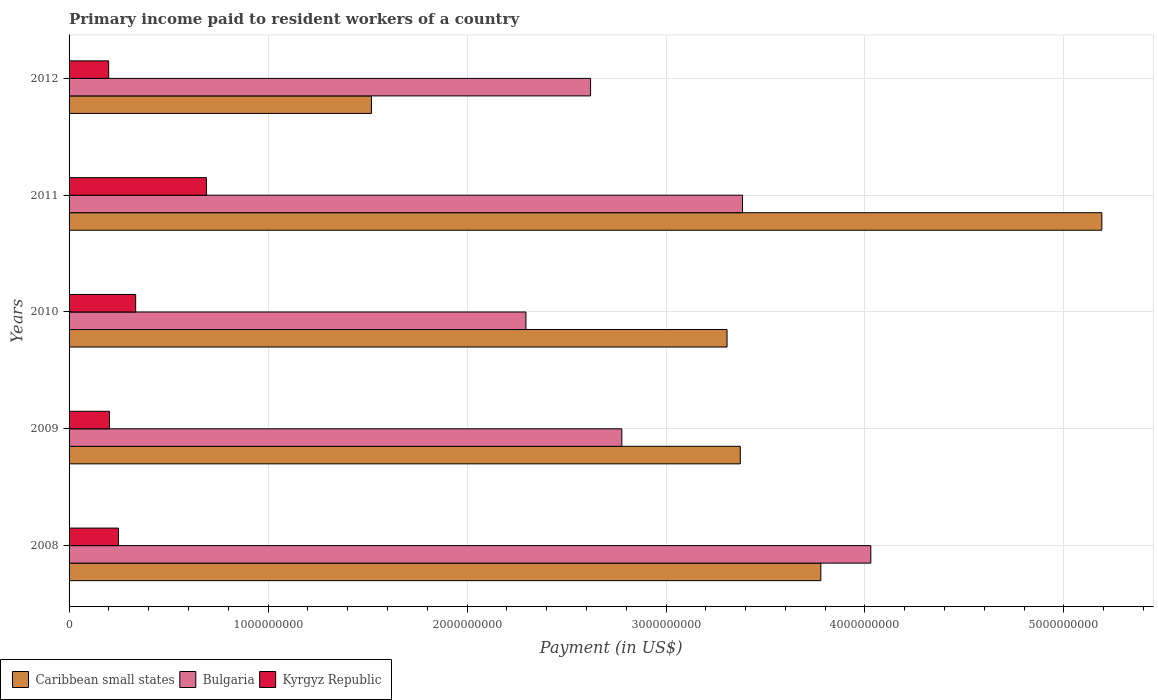How many different coloured bars are there?
Provide a succinct answer. 3. How many groups of bars are there?
Offer a very short reply. 5. Are the number of bars per tick equal to the number of legend labels?
Your answer should be very brief. Yes. Are the number of bars on each tick of the Y-axis equal?
Your response must be concise. Yes. What is the amount paid to workers in Kyrgyz Republic in 2008?
Provide a succinct answer. 2.48e+08. Across all years, what is the maximum amount paid to workers in Kyrgyz Republic?
Give a very brief answer. 6.91e+08. Across all years, what is the minimum amount paid to workers in Bulgaria?
Provide a short and direct response. 2.30e+09. In which year was the amount paid to workers in Bulgaria maximum?
Your response must be concise. 2008. In which year was the amount paid to workers in Caribbean small states minimum?
Offer a very short reply. 2012. What is the total amount paid to workers in Kyrgyz Republic in the graph?
Ensure brevity in your answer.  1.68e+09. What is the difference between the amount paid to workers in Kyrgyz Republic in 2010 and that in 2012?
Ensure brevity in your answer.  1.36e+08. What is the difference between the amount paid to workers in Caribbean small states in 2010 and the amount paid to workers in Bulgaria in 2012?
Offer a very short reply. 6.86e+08. What is the average amount paid to workers in Caribbean small states per year?
Offer a very short reply. 3.43e+09. In the year 2010, what is the difference between the amount paid to workers in Bulgaria and amount paid to workers in Kyrgyz Republic?
Give a very brief answer. 1.96e+09. In how many years, is the amount paid to workers in Kyrgyz Republic greater than 3000000000 US$?
Make the answer very short. 0. What is the ratio of the amount paid to workers in Bulgaria in 2010 to that in 2011?
Provide a succinct answer. 0.68. Is the amount paid to workers in Kyrgyz Republic in 2008 less than that in 2009?
Give a very brief answer. No. Is the difference between the amount paid to workers in Bulgaria in 2010 and 2011 greater than the difference between the amount paid to workers in Kyrgyz Republic in 2010 and 2011?
Provide a short and direct response. No. What is the difference between the highest and the second highest amount paid to workers in Bulgaria?
Provide a succinct answer. 6.45e+08. What is the difference between the highest and the lowest amount paid to workers in Kyrgyz Republic?
Your response must be concise. 4.92e+08. Is the sum of the amount paid to workers in Caribbean small states in 2008 and 2010 greater than the maximum amount paid to workers in Bulgaria across all years?
Make the answer very short. Yes. What does the 2nd bar from the top in 2008 represents?
Provide a succinct answer. Bulgaria. What does the 1st bar from the bottom in 2011 represents?
Your answer should be compact. Caribbean small states. How many bars are there?
Provide a succinct answer. 15. Are all the bars in the graph horizontal?
Your answer should be compact. Yes. Are the values on the major ticks of X-axis written in scientific E-notation?
Your answer should be compact. No. Does the graph contain grids?
Offer a terse response. Yes. How are the legend labels stacked?
Provide a short and direct response. Horizontal. What is the title of the graph?
Give a very brief answer. Primary income paid to resident workers of a country. Does "Ethiopia" appear as one of the legend labels in the graph?
Offer a very short reply. No. What is the label or title of the X-axis?
Ensure brevity in your answer.  Payment (in US$). What is the Payment (in US$) in Caribbean small states in 2008?
Give a very brief answer. 3.78e+09. What is the Payment (in US$) in Bulgaria in 2008?
Make the answer very short. 4.03e+09. What is the Payment (in US$) in Kyrgyz Republic in 2008?
Keep it short and to the point. 2.48e+08. What is the Payment (in US$) in Caribbean small states in 2009?
Ensure brevity in your answer.  3.37e+09. What is the Payment (in US$) in Bulgaria in 2009?
Your answer should be very brief. 2.78e+09. What is the Payment (in US$) of Kyrgyz Republic in 2009?
Keep it short and to the point. 2.03e+08. What is the Payment (in US$) of Caribbean small states in 2010?
Ensure brevity in your answer.  3.31e+09. What is the Payment (in US$) of Bulgaria in 2010?
Your answer should be compact. 2.30e+09. What is the Payment (in US$) of Kyrgyz Republic in 2010?
Your answer should be compact. 3.35e+08. What is the Payment (in US$) in Caribbean small states in 2011?
Your answer should be compact. 5.19e+09. What is the Payment (in US$) of Bulgaria in 2011?
Your response must be concise. 3.38e+09. What is the Payment (in US$) of Kyrgyz Republic in 2011?
Your response must be concise. 6.91e+08. What is the Payment (in US$) of Caribbean small states in 2012?
Give a very brief answer. 1.52e+09. What is the Payment (in US$) of Bulgaria in 2012?
Give a very brief answer. 2.62e+09. What is the Payment (in US$) of Kyrgyz Republic in 2012?
Offer a very short reply. 1.99e+08. Across all years, what is the maximum Payment (in US$) in Caribbean small states?
Your response must be concise. 5.19e+09. Across all years, what is the maximum Payment (in US$) of Bulgaria?
Give a very brief answer. 4.03e+09. Across all years, what is the maximum Payment (in US$) of Kyrgyz Republic?
Your answer should be compact. 6.91e+08. Across all years, what is the minimum Payment (in US$) of Caribbean small states?
Your response must be concise. 1.52e+09. Across all years, what is the minimum Payment (in US$) of Bulgaria?
Keep it short and to the point. 2.30e+09. Across all years, what is the minimum Payment (in US$) in Kyrgyz Republic?
Keep it short and to the point. 1.99e+08. What is the total Payment (in US$) in Caribbean small states in the graph?
Provide a succinct answer. 1.72e+1. What is the total Payment (in US$) of Bulgaria in the graph?
Make the answer very short. 1.51e+1. What is the total Payment (in US$) of Kyrgyz Republic in the graph?
Offer a very short reply. 1.68e+09. What is the difference between the Payment (in US$) of Caribbean small states in 2008 and that in 2009?
Your response must be concise. 4.05e+08. What is the difference between the Payment (in US$) in Bulgaria in 2008 and that in 2009?
Provide a succinct answer. 1.25e+09. What is the difference between the Payment (in US$) in Kyrgyz Republic in 2008 and that in 2009?
Provide a succinct answer. 4.53e+07. What is the difference between the Payment (in US$) in Caribbean small states in 2008 and that in 2010?
Your answer should be compact. 4.71e+08. What is the difference between the Payment (in US$) of Bulgaria in 2008 and that in 2010?
Provide a short and direct response. 1.73e+09. What is the difference between the Payment (in US$) in Kyrgyz Republic in 2008 and that in 2010?
Keep it short and to the point. -8.63e+07. What is the difference between the Payment (in US$) of Caribbean small states in 2008 and that in 2011?
Ensure brevity in your answer.  -1.41e+09. What is the difference between the Payment (in US$) of Bulgaria in 2008 and that in 2011?
Keep it short and to the point. 6.45e+08. What is the difference between the Payment (in US$) in Kyrgyz Republic in 2008 and that in 2011?
Provide a short and direct response. -4.42e+08. What is the difference between the Payment (in US$) in Caribbean small states in 2008 and that in 2012?
Offer a very short reply. 2.26e+09. What is the difference between the Payment (in US$) of Bulgaria in 2008 and that in 2012?
Offer a terse response. 1.41e+09. What is the difference between the Payment (in US$) in Kyrgyz Republic in 2008 and that in 2012?
Ensure brevity in your answer.  4.94e+07. What is the difference between the Payment (in US$) of Caribbean small states in 2009 and that in 2010?
Offer a terse response. 6.67e+07. What is the difference between the Payment (in US$) in Bulgaria in 2009 and that in 2010?
Keep it short and to the point. 4.82e+08. What is the difference between the Payment (in US$) of Kyrgyz Republic in 2009 and that in 2010?
Keep it short and to the point. -1.32e+08. What is the difference between the Payment (in US$) in Caribbean small states in 2009 and that in 2011?
Offer a terse response. -1.82e+09. What is the difference between the Payment (in US$) in Bulgaria in 2009 and that in 2011?
Offer a terse response. -6.07e+08. What is the difference between the Payment (in US$) of Kyrgyz Republic in 2009 and that in 2011?
Your answer should be very brief. -4.88e+08. What is the difference between the Payment (in US$) in Caribbean small states in 2009 and that in 2012?
Ensure brevity in your answer.  1.85e+09. What is the difference between the Payment (in US$) in Bulgaria in 2009 and that in 2012?
Your response must be concise. 1.57e+08. What is the difference between the Payment (in US$) of Kyrgyz Republic in 2009 and that in 2012?
Your answer should be very brief. 4.12e+06. What is the difference between the Payment (in US$) in Caribbean small states in 2010 and that in 2011?
Offer a very short reply. -1.88e+09. What is the difference between the Payment (in US$) in Bulgaria in 2010 and that in 2011?
Give a very brief answer. -1.09e+09. What is the difference between the Payment (in US$) in Kyrgyz Republic in 2010 and that in 2011?
Offer a very short reply. -3.56e+08. What is the difference between the Payment (in US$) of Caribbean small states in 2010 and that in 2012?
Provide a short and direct response. 1.79e+09. What is the difference between the Payment (in US$) in Bulgaria in 2010 and that in 2012?
Provide a succinct answer. -3.25e+08. What is the difference between the Payment (in US$) of Kyrgyz Republic in 2010 and that in 2012?
Your response must be concise. 1.36e+08. What is the difference between the Payment (in US$) of Caribbean small states in 2011 and that in 2012?
Provide a succinct answer. 3.67e+09. What is the difference between the Payment (in US$) of Bulgaria in 2011 and that in 2012?
Give a very brief answer. 7.64e+08. What is the difference between the Payment (in US$) of Kyrgyz Republic in 2011 and that in 2012?
Ensure brevity in your answer.  4.92e+08. What is the difference between the Payment (in US$) in Caribbean small states in 2008 and the Payment (in US$) in Bulgaria in 2009?
Your response must be concise. 1.00e+09. What is the difference between the Payment (in US$) of Caribbean small states in 2008 and the Payment (in US$) of Kyrgyz Republic in 2009?
Offer a very short reply. 3.58e+09. What is the difference between the Payment (in US$) of Bulgaria in 2008 and the Payment (in US$) of Kyrgyz Republic in 2009?
Keep it short and to the point. 3.83e+09. What is the difference between the Payment (in US$) of Caribbean small states in 2008 and the Payment (in US$) of Bulgaria in 2010?
Ensure brevity in your answer.  1.48e+09. What is the difference between the Payment (in US$) of Caribbean small states in 2008 and the Payment (in US$) of Kyrgyz Republic in 2010?
Your answer should be very brief. 3.44e+09. What is the difference between the Payment (in US$) of Bulgaria in 2008 and the Payment (in US$) of Kyrgyz Republic in 2010?
Make the answer very short. 3.69e+09. What is the difference between the Payment (in US$) of Caribbean small states in 2008 and the Payment (in US$) of Bulgaria in 2011?
Give a very brief answer. 3.94e+08. What is the difference between the Payment (in US$) of Caribbean small states in 2008 and the Payment (in US$) of Kyrgyz Republic in 2011?
Ensure brevity in your answer.  3.09e+09. What is the difference between the Payment (in US$) of Bulgaria in 2008 and the Payment (in US$) of Kyrgyz Republic in 2011?
Offer a terse response. 3.34e+09. What is the difference between the Payment (in US$) of Caribbean small states in 2008 and the Payment (in US$) of Bulgaria in 2012?
Provide a short and direct response. 1.16e+09. What is the difference between the Payment (in US$) in Caribbean small states in 2008 and the Payment (in US$) in Kyrgyz Republic in 2012?
Give a very brief answer. 3.58e+09. What is the difference between the Payment (in US$) of Bulgaria in 2008 and the Payment (in US$) of Kyrgyz Republic in 2012?
Make the answer very short. 3.83e+09. What is the difference between the Payment (in US$) in Caribbean small states in 2009 and the Payment (in US$) in Bulgaria in 2010?
Your response must be concise. 1.08e+09. What is the difference between the Payment (in US$) of Caribbean small states in 2009 and the Payment (in US$) of Kyrgyz Republic in 2010?
Your answer should be compact. 3.04e+09. What is the difference between the Payment (in US$) in Bulgaria in 2009 and the Payment (in US$) in Kyrgyz Republic in 2010?
Your answer should be very brief. 2.44e+09. What is the difference between the Payment (in US$) of Caribbean small states in 2009 and the Payment (in US$) of Bulgaria in 2011?
Ensure brevity in your answer.  -1.11e+07. What is the difference between the Payment (in US$) of Caribbean small states in 2009 and the Payment (in US$) of Kyrgyz Republic in 2011?
Make the answer very short. 2.68e+09. What is the difference between the Payment (in US$) of Bulgaria in 2009 and the Payment (in US$) of Kyrgyz Republic in 2011?
Provide a short and direct response. 2.09e+09. What is the difference between the Payment (in US$) of Caribbean small states in 2009 and the Payment (in US$) of Bulgaria in 2012?
Provide a short and direct response. 7.53e+08. What is the difference between the Payment (in US$) in Caribbean small states in 2009 and the Payment (in US$) in Kyrgyz Republic in 2012?
Make the answer very short. 3.17e+09. What is the difference between the Payment (in US$) in Bulgaria in 2009 and the Payment (in US$) in Kyrgyz Republic in 2012?
Ensure brevity in your answer.  2.58e+09. What is the difference between the Payment (in US$) of Caribbean small states in 2010 and the Payment (in US$) of Bulgaria in 2011?
Your answer should be very brief. -7.78e+07. What is the difference between the Payment (in US$) of Caribbean small states in 2010 and the Payment (in US$) of Kyrgyz Republic in 2011?
Your answer should be compact. 2.62e+09. What is the difference between the Payment (in US$) of Bulgaria in 2010 and the Payment (in US$) of Kyrgyz Republic in 2011?
Your answer should be compact. 1.61e+09. What is the difference between the Payment (in US$) in Caribbean small states in 2010 and the Payment (in US$) in Bulgaria in 2012?
Your answer should be compact. 6.86e+08. What is the difference between the Payment (in US$) of Caribbean small states in 2010 and the Payment (in US$) of Kyrgyz Republic in 2012?
Give a very brief answer. 3.11e+09. What is the difference between the Payment (in US$) in Bulgaria in 2010 and the Payment (in US$) in Kyrgyz Republic in 2012?
Keep it short and to the point. 2.10e+09. What is the difference between the Payment (in US$) of Caribbean small states in 2011 and the Payment (in US$) of Bulgaria in 2012?
Keep it short and to the point. 2.57e+09. What is the difference between the Payment (in US$) of Caribbean small states in 2011 and the Payment (in US$) of Kyrgyz Republic in 2012?
Offer a terse response. 4.99e+09. What is the difference between the Payment (in US$) of Bulgaria in 2011 and the Payment (in US$) of Kyrgyz Republic in 2012?
Provide a short and direct response. 3.19e+09. What is the average Payment (in US$) of Caribbean small states per year?
Provide a succinct answer. 3.43e+09. What is the average Payment (in US$) in Bulgaria per year?
Offer a terse response. 3.02e+09. What is the average Payment (in US$) of Kyrgyz Republic per year?
Offer a very short reply. 3.35e+08. In the year 2008, what is the difference between the Payment (in US$) of Caribbean small states and Payment (in US$) of Bulgaria?
Ensure brevity in your answer.  -2.51e+08. In the year 2008, what is the difference between the Payment (in US$) of Caribbean small states and Payment (in US$) of Kyrgyz Republic?
Provide a short and direct response. 3.53e+09. In the year 2008, what is the difference between the Payment (in US$) in Bulgaria and Payment (in US$) in Kyrgyz Republic?
Your answer should be very brief. 3.78e+09. In the year 2009, what is the difference between the Payment (in US$) in Caribbean small states and Payment (in US$) in Bulgaria?
Provide a succinct answer. 5.95e+08. In the year 2009, what is the difference between the Payment (in US$) of Caribbean small states and Payment (in US$) of Kyrgyz Republic?
Keep it short and to the point. 3.17e+09. In the year 2009, what is the difference between the Payment (in US$) of Bulgaria and Payment (in US$) of Kyrgyz Republic?
Your answer should be very brief. 2.57e+09. In the year 2010, what is the difference between the Payment (in US$) in Caribbean small states and Payment (in US$) in Bulgaria?
Provide a succinct answer. 1.01e+09. In the year 2010, what is the difference between the Payment (in US$) of Caribbean small states and Payment (in US$) of Kyrgyz Republic?
Keep it short and to the point. 2.97e+09. In the year 2010, what is the difference between the Payment (in US$) in Bulgaria and Payment (in US$) in Kyrgyz Republic?
Offer a terse response. 1.96e+09. In the year 2011, what is the difference between the Payment (in US$) of Caribbean small states and Payment (in US$) of Bulgaria?
Keep it short and to the point. 1.81e+09. In the year 2011, what is the difference between the Payment (in US$) in Caribbean small states and Payment (in US$) in Kyrgyz Republic?
Make the answer very short. 4.50e+09. In the year 2011, what is the difference between the Payment (in US$) in Bulgaria and Payment (in US$) in Kyrgyz Republic?
Offer a terse response. 2.69e+09. In the year 2012, what is the difference between the Payment (in US$) in Caribbean small states and Payment (in US$) in Bulgaria?
Keep it short and to the point. -1.10e+09. In the year 2012, what is the difference between the Payment (in US$) of Caribbean small states and Payment (in US$) of Kyrgyz Republic?
Your answer should be compact. 1.32e+09. In the year 2012, what is the difference between the Payment (in US$) in Bulgaria and Payment (in US$) in Kyrgyz Republic?
Offer a very short reply. 2.42e+09. What is the ratio of the Payment (in US$) of Caribbean small states in 2008 to that in 2009?
Ensure brevity in your answer.  1.12. What is the ratio of the Payment (in US$) in Bulgaria in 2008 to that in 2009?
Your answer should be very brief. 1.45. What is the ratio of the Payment (in US$) of Kyrgyz Republic in 2008 to that in 2009?
Your answer should be very brief. 1.22. What is the ratio of the Payment (in US$) of Caribbean small states in 2008 to that in 2010?
Ensure brevity in your answer.  1.14. What is the ratio of the Payment (in US$) in Bulgaria in 2008 to that in 2010?
Make the answer very short. 1.75. What is the ratio of the Payment (in US$) of Kyrgyz Republic in 2008 to that in 2010?
Offer a very short reply. 0.74. What is the ratio of the Payment (in US$) in Caribbean small states in 2008 to that in 2011?
Ensure brevity in your answer.  0.73. What is the ratio of the Payment (in US$) of Bulgaria in 2008 to that in 2011?
Give a very brief answer. 1.19. What is the ratio of the Payment (in US$) of Kyrgyz Republic in 2008 to that in 2011?
Your answer should be very brief. 0.36. What is the ratio of the Payment (in US$) in Caribbean small states in 2008 to that in 2012?
Provide a short and direct response. 2.49. What is the ratio of the Payment (in US$) of Bulgaria in 2008 to that in 2012?
Ensure brevity in your answer.  1.54. What is the ratio of the Payment (in US$) of Kyrgyz Republic in 2008 to that in 2012?
Ensure brevity in your answer.  1.25. What is the ratio of the Payment (in US$) of Caribbean small states in 2009 to that in 2010?
Offer a terse response. 1.02. What is the ratio of the Payment (in US$) of Bulgaria in 2009 to that in 2010?
Offer a very short reply. 1.21. What is the ratio of the Payment (in US$) in Kyrgyz Republic in 2009 to that in 2010?
Keep it short and to the point. 0.61. What is the ratio of the Payment (in US$) in Caribbean small states in 2009 to that in 2011?
Give a very brief answer. 0.65. What is the ratio of the Payment (in US$) of Bulgaria in 2009 to that in 2011?
Provide a short and direct response. 0.82. What is the ratio of the Payment (in US$) in Kyrgyz Republic in 2009 to that in 2011?
Offer a very short reply. 0.29. What is the ratio of the Payment (in US$) of Caribbean small states in 2009 to that in 2012?
Keep it short and to the point. 2.22. What is the ratio of the Payment (in US$) in Bulgaria in 2009 to that in 2012?
Keep it short and to the point. 1.06. What is the ratio of the Payment (in US$) in Kyrgyz Republic in 2009 to that in 2012?
Your answer should be very brief. 1.02. What is the ratio of the Payment (in US$) of Caribbean small states in 2010 to that in 2011?
Give a very brief answer. 0.64. What is the ratio of the Payment (in US$) of Bulgaria in 2010 to that in 2011?
Keep it short and to the point. 0.68. What is the ratio of the Payment (in US$) in Kyrgyz Republic in 2010 to that in 2011?
Your answer should be very brief. 0.48. What is the ratio of the Payment (in US$) in Caribbean small states in 2010 to that in 2012?
Keep it short and to the point. 2.18. What is the ratio of the Payment (in US$) in Bulgaria in 2010 to that in 2012?
Your answer should be very brief. 0.88. What is the ratio of the Payment (in US$) in Kyrgyz Republic in 2010 to that in 2012?
Give a very brief answer. 1.68. What is the ratio of the Payment (in US$) in Caribbean small states in 2011 to that in 2012?
Provide a short and direct response. 3.42. What is the ratio of the Payment (in US$) in Bulgaria in 2011 to that in 2012?
Provide a succinct answer. 1.29. What is the ratio of the Payment (in US$) of Kyrgyz Republic in 2011 to that in 2012?
Ensure brevity in your answer.  3.47. What is the difference between the highest and the second highest Payment (in US$) in Caribbean small states?
Make the answer very short. 1.41e+09. What is the difference between the highest and the second highest Payment (in US$) in Bulgaria?
Offer a terse response. 6.45e+08. What is the difference between the highest and the second highest Payment (in US$) in Kyrgyz Republic?
Make the answer very short. 3.56e+08. What is the difference between the highest and the lowest Payment (in US$) of Caribbean small states?
Your answer should be compact. 3.67e+09. What is the difference between the highest and the lowest Payment (in US$) of Bulgaria?
Offer a very short reply. 1.73e+09. What is the difference between the highest and the lowest Payment (in US$) in Kyrgyz Republic?
Keep it short and to the point. 4.92e+08. 